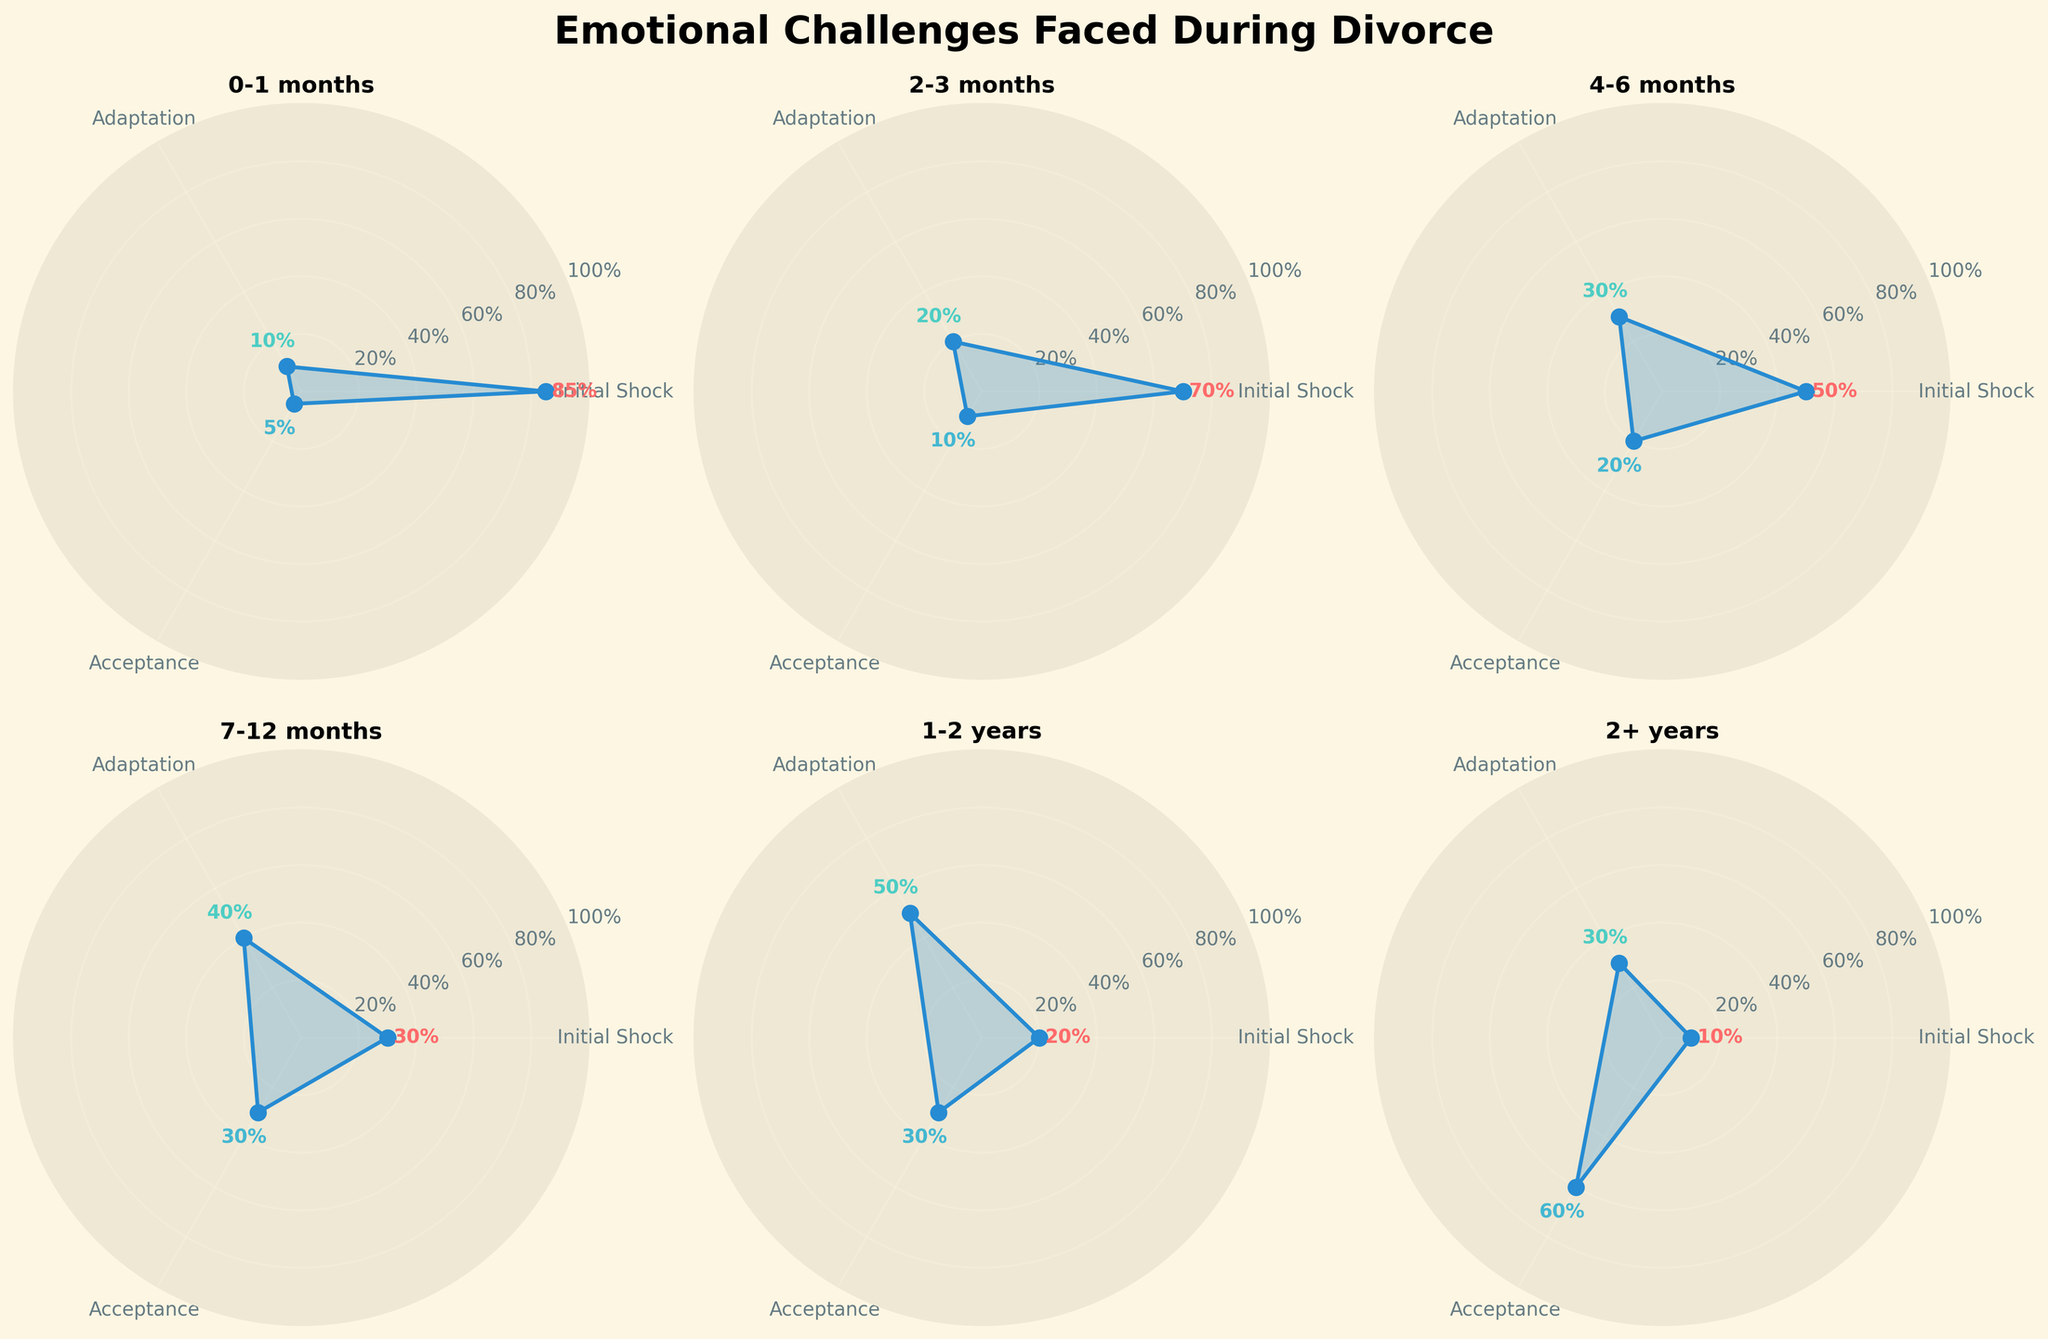What's the title of the figure? The title is usually located at the top of the figure. In this case, it clearly states 'Emotional Challenges Faced During Divorce.'
Answer: Emotional Challenges Faced During Divorce What are the categories represented in each subplot? The categories are usually labeled around the polar chart. They are 'Initial Shock,' 'Adaptation,' and 'Acceptance.'
Answer: Initial Shock, Adaptation, Acceptance Which time period has the highest initial shock? By checking each subplot, you can find the highest initial shock percentage at '0-1 months' with a value of 85%.
Answer: 0-1 months In which time period does acceptance surpass initial shock for the first time? Compare the values for each time period. Acceptance first surpasses initial shock at the '2+ years' period (60% for acceptance vs. 10% for initial shock).
Answer: 2+ years What trend is observed in initial shock as time since filing increases? Observe the initial shock values across each subplot in chronological order. The initial shock values consistently decrease from 85% (0-1 months) to 10% (2+ years).
Answer: Decreasing trend Which time period has the least adaptation? By comparing adaptation values, the '0-1 months' period has the least adaptation with only 10%.
Answer: 0-1 months What is the difference between adaptation and acceptance in the 7-12 months period? Look at the corresponding subplot and identify the values: adaptation is 40%, and acceptance is 30%. The difference is 40% - 30% = 10%.
Answer: 10% How does the pattern of acceptance evolve over time? Analyze acceptance values across the time periods. Acceptance starts at 5% (0-1 months), gradually increases to 30% (by 1-2 years), and sharply rises to 60% at 2+ years.
Answer: Increasing trend Which time period has the most balanced distribution of emotional challenges? Look for the period with values most similar across all three categories. '2-3 months' with 70% initial shock, 20% adaptation, and 10% acceptance seems less balanced compared to '7-12 months' with 30%, 40%, and 30% respectively.
Answer: 7-12 months What is the common emotional challenge at the 4-6 months period? By looking at the 4-6 months subplot, the majority emotional challenge is initial shock at 50%, which is the highest value among the three categories.
Answer: Initial Shock 